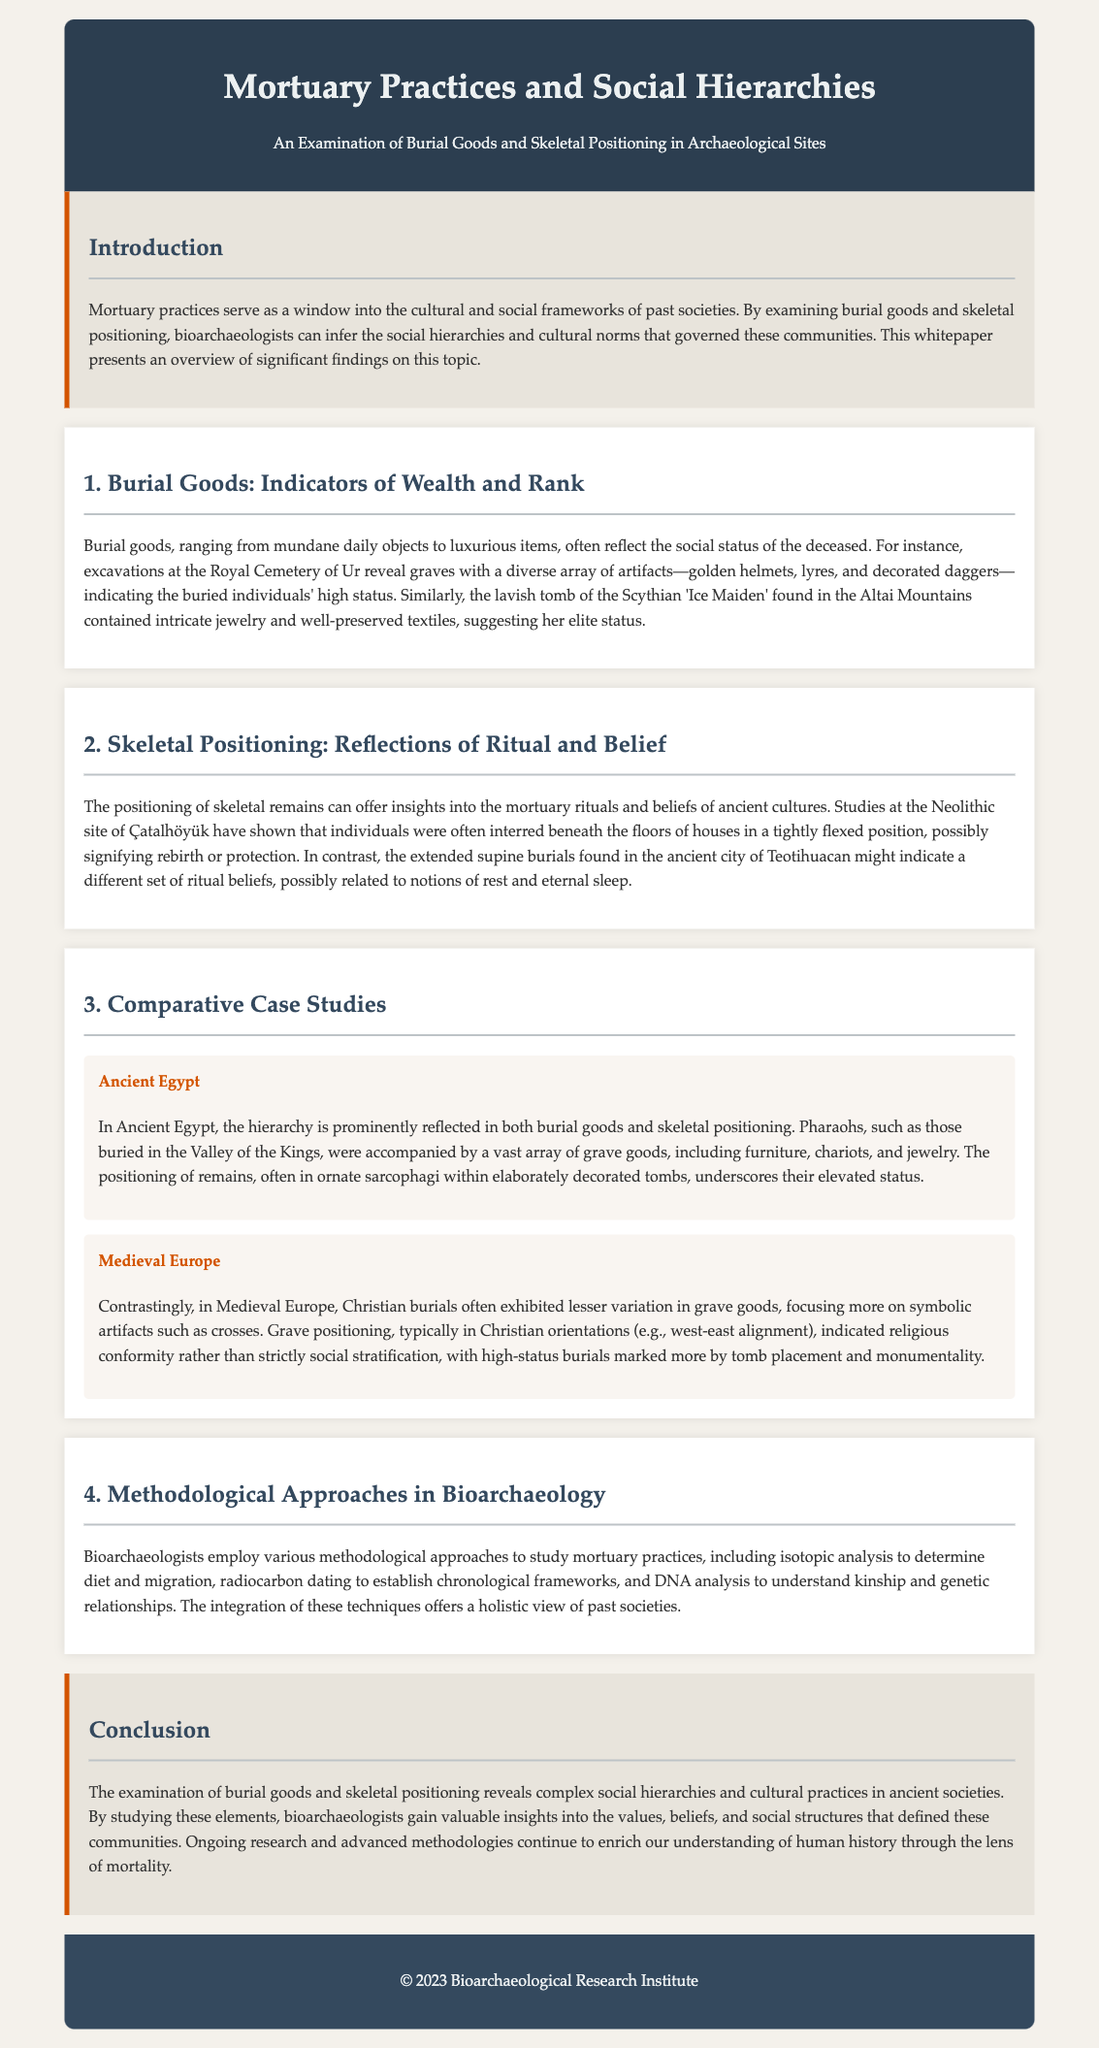What are mortuary practices? Mortuary practices are a window into the cultural and social frameworks of past societies, examined through burial goods and skeletal positioning.
Answer: A window into cultural and social frameworks What items were found in the Royal Cemetery of Ur? The Royal Cemetery of Ur revealed graves with a diverse array of artifacts, including golden helmets, lyres, and decorated daggers, indicating high status.
Answer: Golden helmets, lyres, decorated daggers How were individuals interred at Çatalhöyük? Individuals were often interred beneath the floors of houses in a tightly flexed position, possibly signifying rebirth or protection.
Answer: Tightly flexed position Which ancient site exemplifies the use of elaborate sarcophagi for pharaohs? The Valley of the Kings exemplifies the use of elaborate sarcophagi for pharaohs, who were accompanied by a vast array of grave goods.
Answer: Valley of the Kings What burial orientation was typical in Medieval Europe? Grave positioning in Medieval Europe typically aligned west-east, indicating religious conformity rather than strictly social stratification.
Answer: West-east alignment What methodological approach can be used to determine diet in bioarchaeology? Isotopic analysis can be employed to determine diet in bioarchaeology.
Answer: Isotopic analysis What does the study of burial goods reveal about ancient societies? The examination of burial goods reveals complex social hierarchies and cultural practices that defined ancient societies.
Answer: Complex social hierarchies and cultural practices Which artifact type indicated higher social status in ancient Egypt? In Ancient Egypt, the vast array of grave goods including furniture, chariots, and jewelry indicated higher social status.
Answer: Grave goods Which elite burial was discovered in the Altai Mountains? The lavish tomb of the Scythian 'Ice Maiden' was discovered in the Altai Mountains, suggesting her elite status.
Answer: Scythian 'Ice Maiden' 